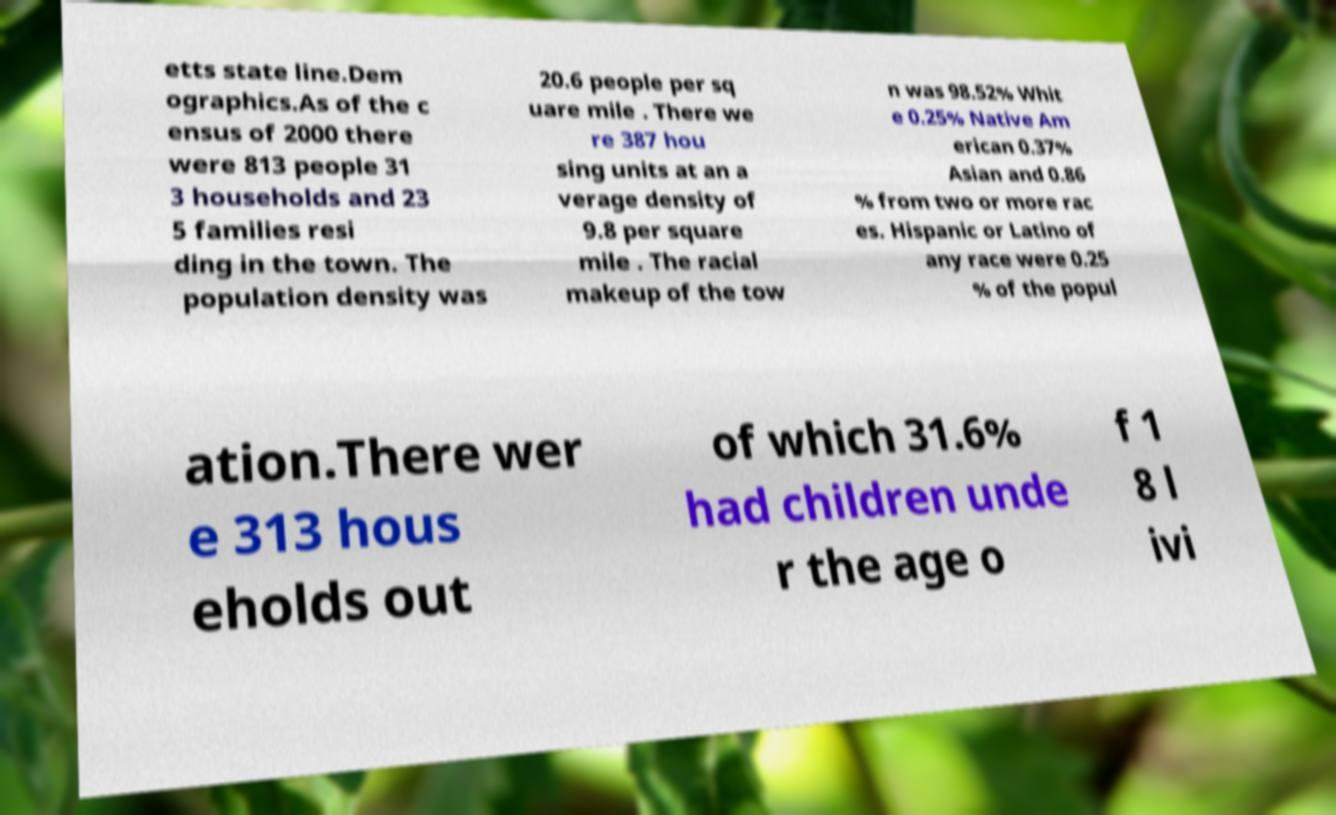Please identify and transcribe the text found in this image. etts state line.Dem ographics.As of the c ensus of 2000 there were 813 people 31 3 households and 23 5 families resi ding in the town. The population density was 20.6 people per sq uare mile . There we re 387 hou sing units at an a verage density of 9.8 per square mile . The racial makeup of the tow n was 98.52% Whit e 0.25% Native Am erican 0.37% Asian and 0.86 % from two or more rac es. Hispanic or Latino of any race were 0.25 % of the popul ation.There wer e 313 hous eholds out of which 31.6% had children unde r the age o f 1 8 l ivi 